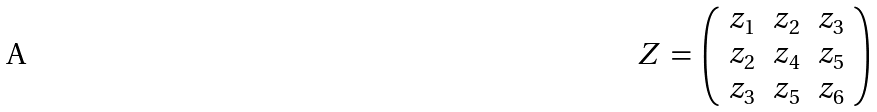Convert formula to latex. <formula><loc_0><loc_0><loc_500><loc_500>Z \, = \, \left ( \begin{array} { l l l } z _ { 1 } & z _ { 2 } & z _ { 3 } \\ z _ { 2 } & z _ { 4 } & z _ { 5 } \\ z _ { 3 } & z _ { 5 } & z _ { 6 } \end{array} \right )</formula> 